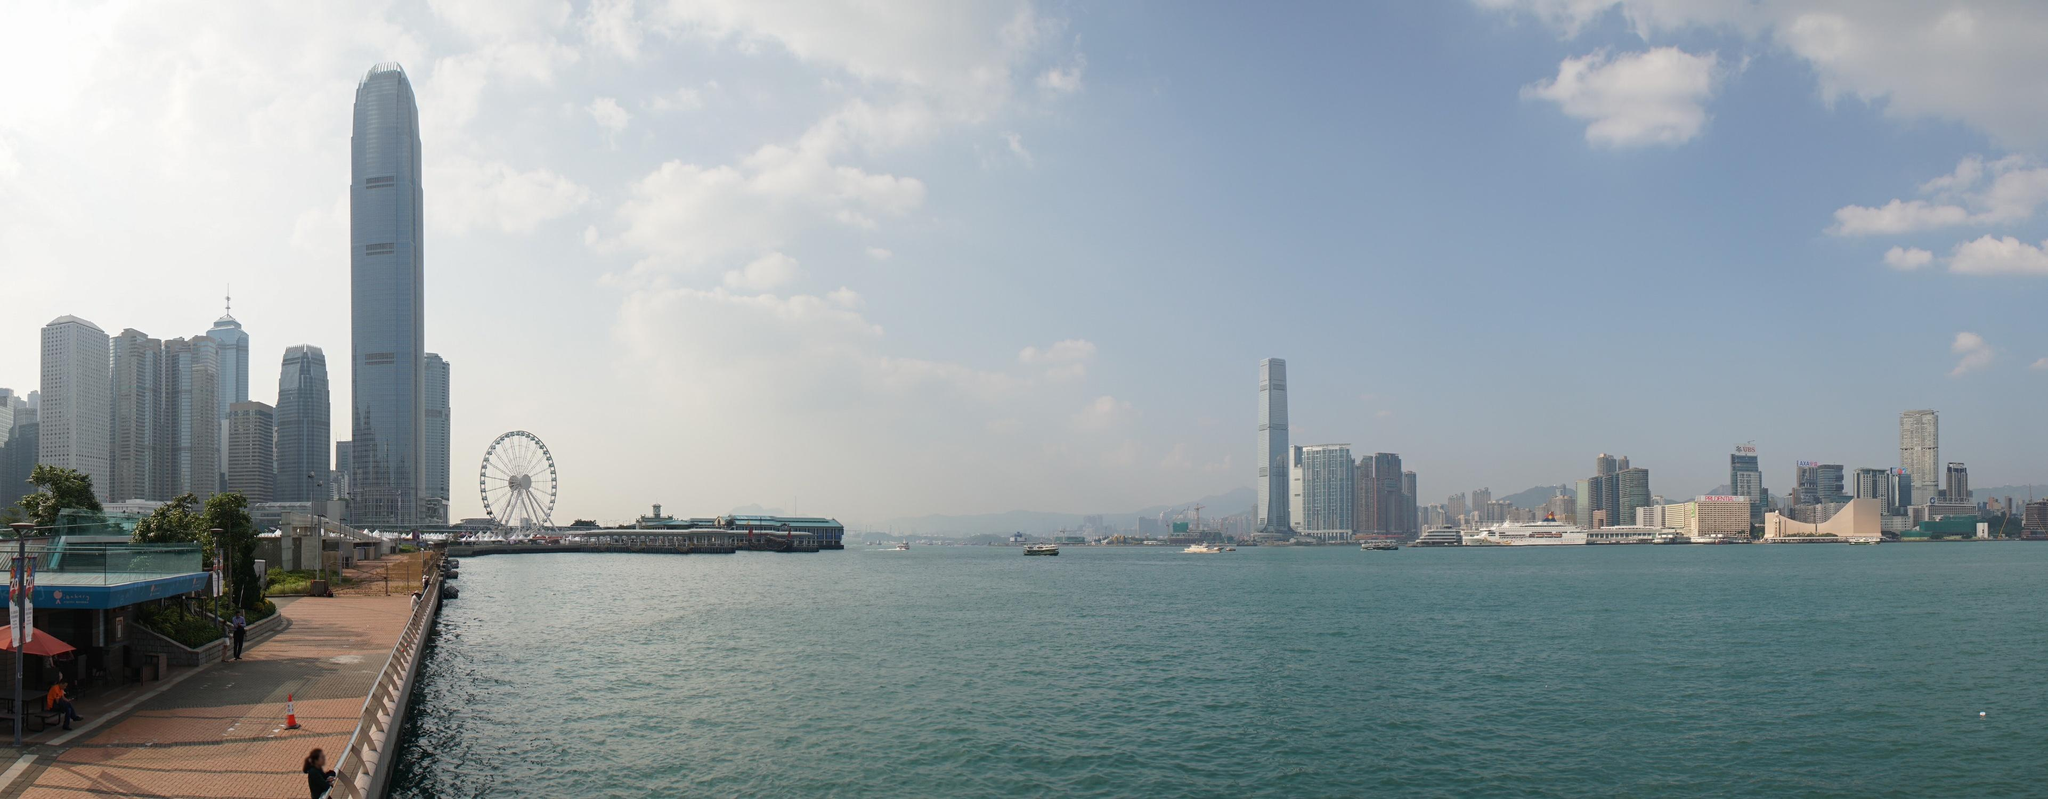Imagine a futuristic scenario here. What advancements do you see and how do they impact the people? In a futuristic scenario, the waterfront could transform into a hub of technological marvels. Picture autonomous electric ferries gliding smoothly across the harbor, offering efficient and eco-friendly transportation. The skyscrapers could be adorned with intelligent lighting systems powered by renewable energy, enhancing both aesthetics and sustainability. Smart promenades equipped with interactive information panels and augmented reality experiences could provide visitors with historical and cultural insights right at their fingertips. Holographic art displays and drone light shows might become popular attractions, adding a new dimension to the entertainment landscape. These advancements would not only enhance the visual appeal but also improve the quality of life for residents, offering a seamless blend of nature, technology, and urban sophistication. Can you tell me a short story about a local individual who comes to this waterfront every day? Every day, an elderly man named Mr. Lee comes to this waterfront. For him, it is a place of solace and nostalgia. As a young man, he used to work in one of the tall buildings overlooking the harbor. Now retired, he finds peace in watching the ferries come and go, recalling the hustle and bustle of his younger days. He chats with familiar faces, sharing stories of the past, and sometimes sits quietly reading a book. For him, this waterfront is a cherished slice of the city, where memories and the present blend seamlessly. 